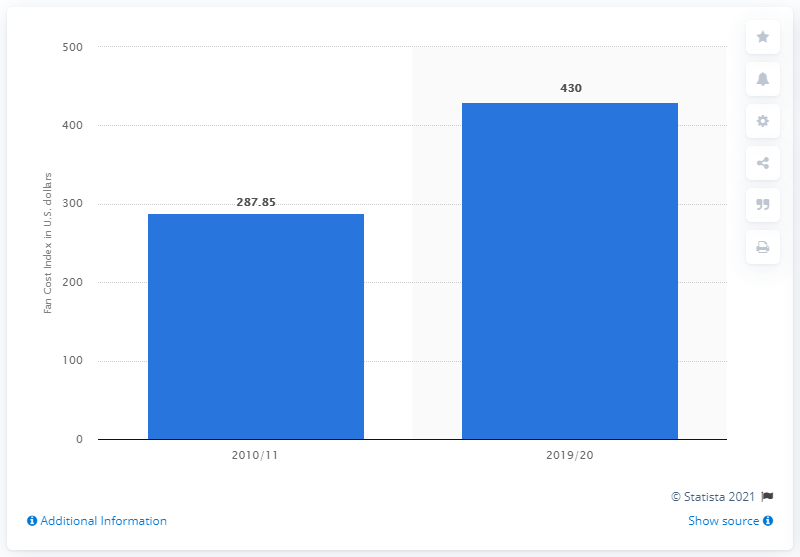Give some essential details in this illustration. The average of the two blue bars is 358.93. The value of the highest blue bar is 430. 